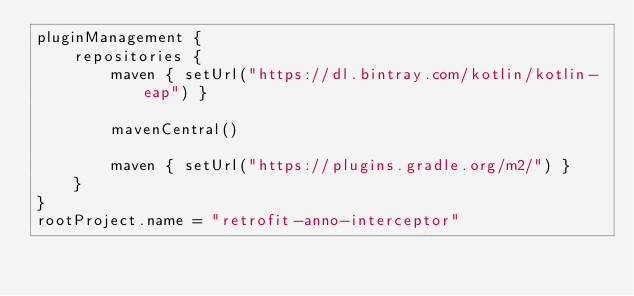<code> <loc_0><loc_0><loc_500><loc_500><_Kotlin_>pluginManagement {
    repositories {
        maven { setUrl("https://dl.bintray.com/kotlin/kotlin-eap") }

        mavenCentral()

        maven { setUrl("https://plugins.gradle.org/m2/") }
    }
}
rootProject.name = "retrofit-anno-interceptor"

</code> 